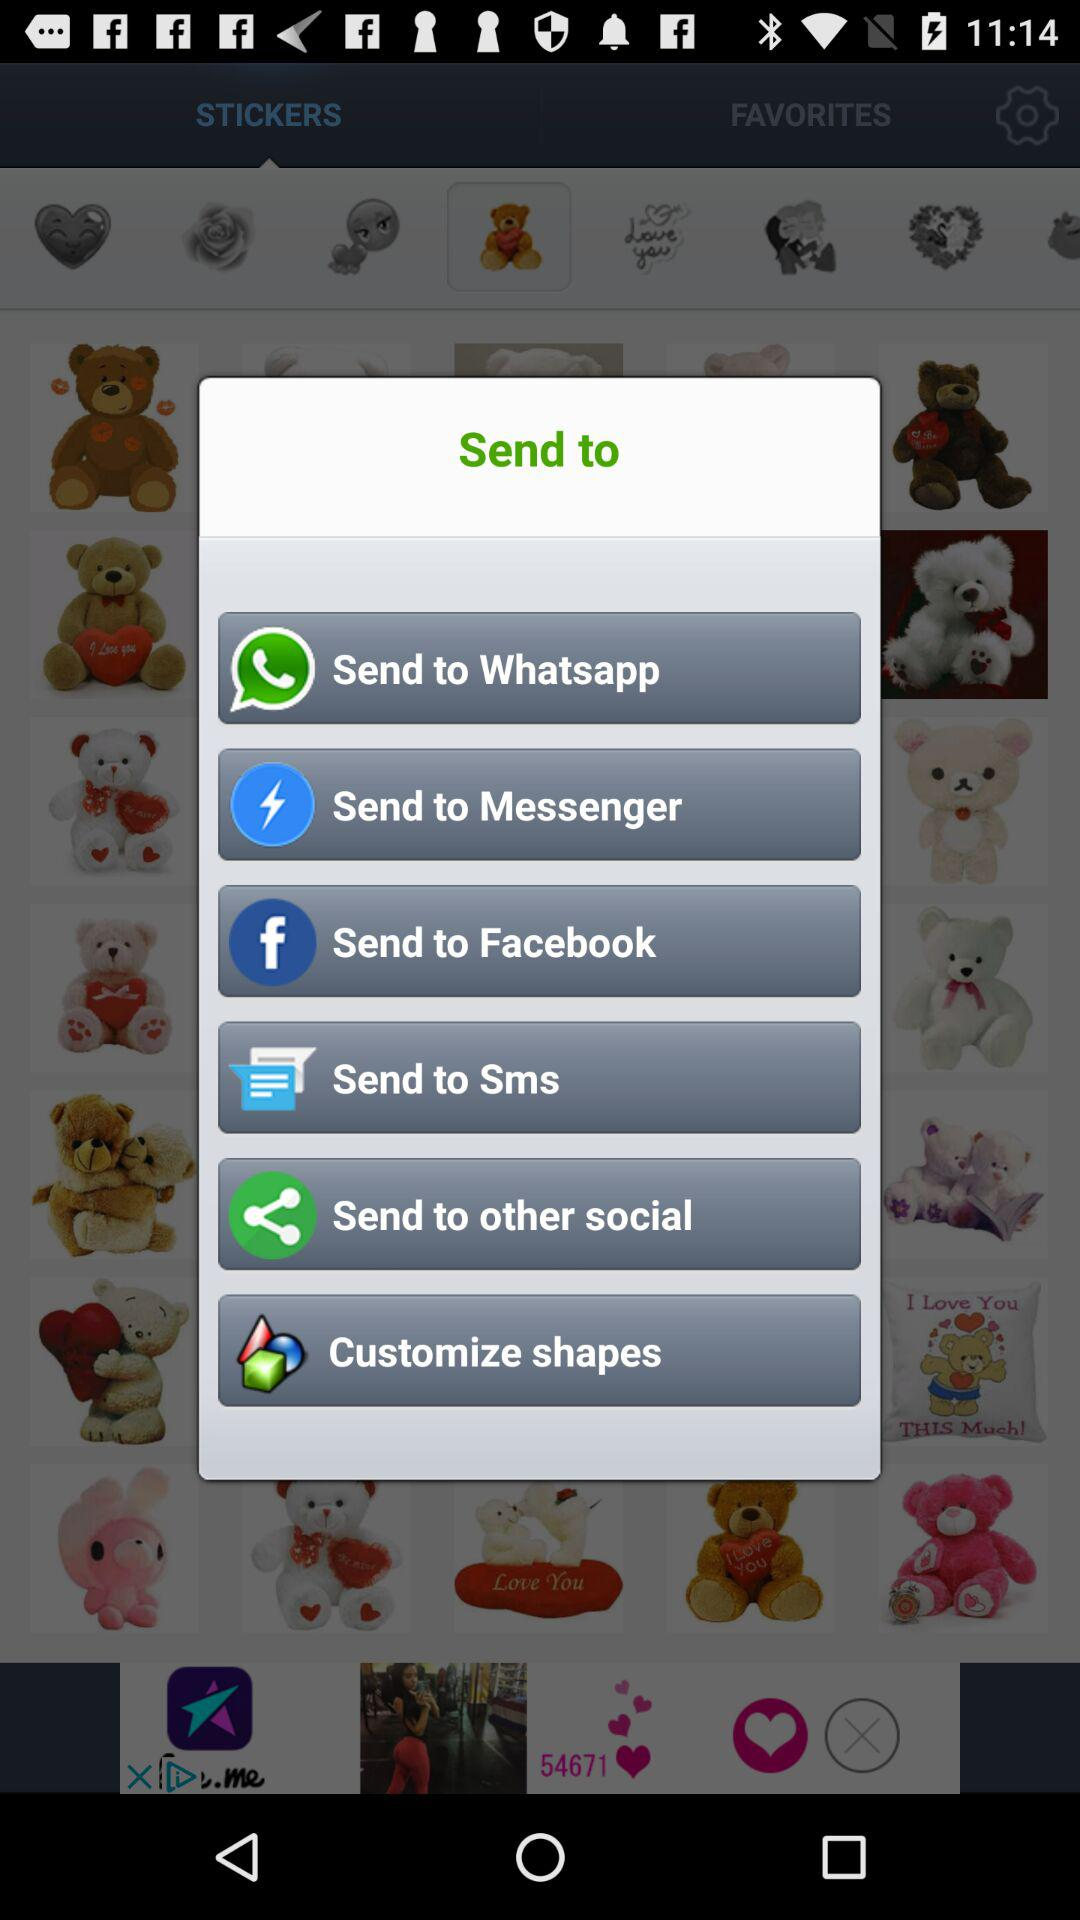What applications can be used to send the content? The applications that can be used to send the content are "Whatsapp", "Messenger" and "Facebook". 